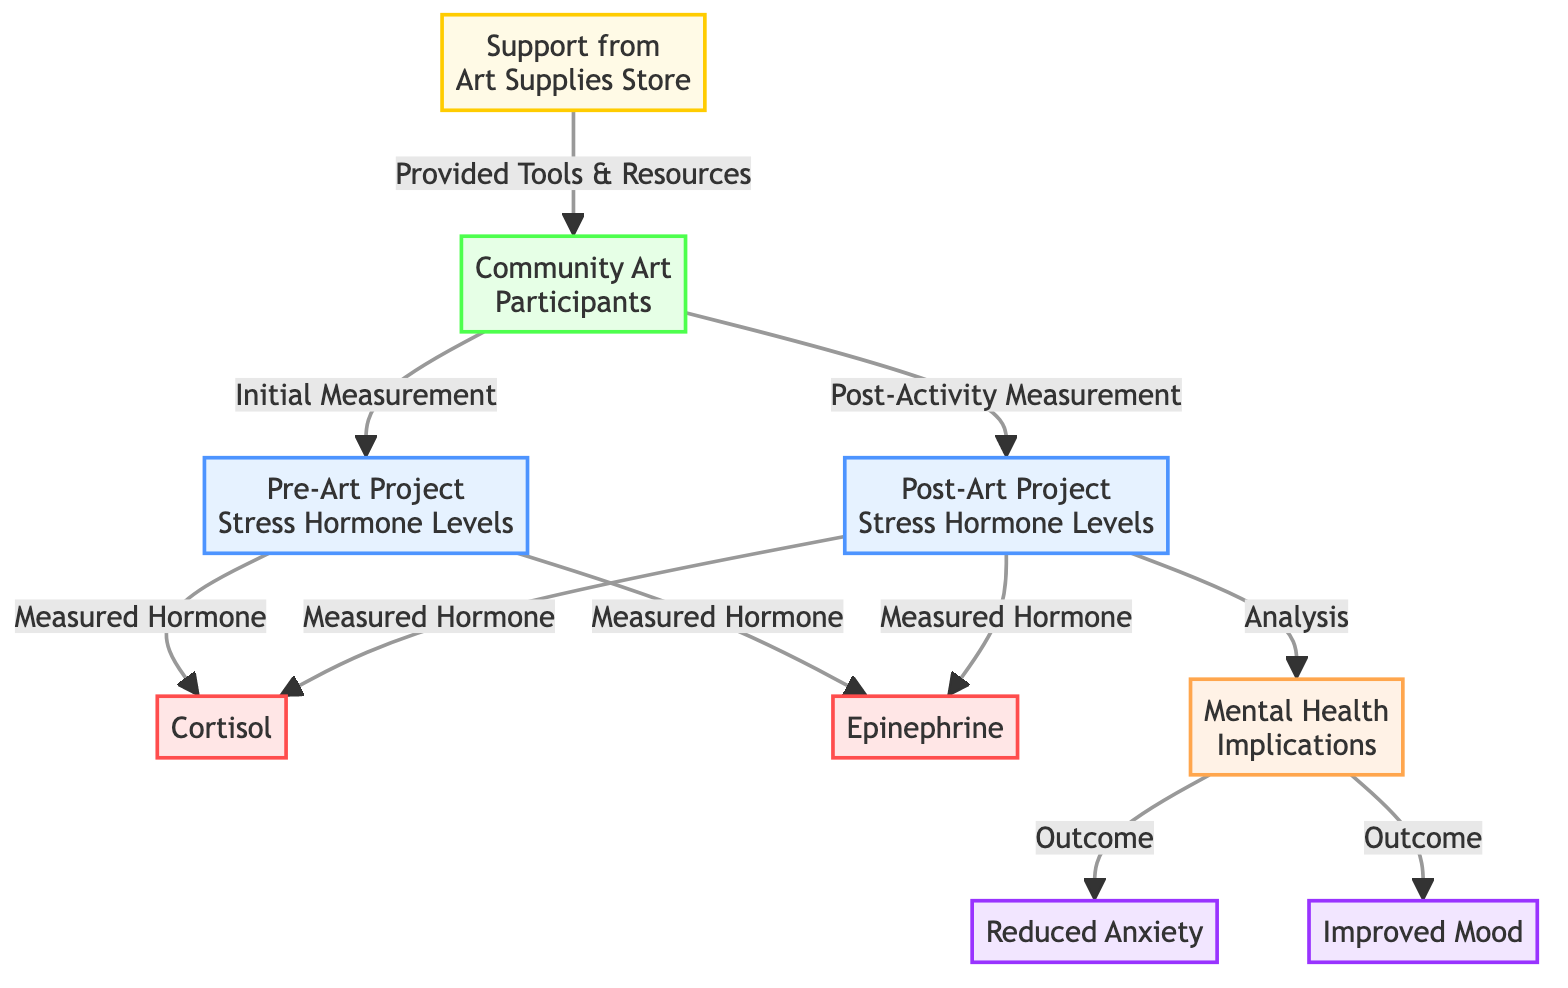What are the two types of stress hormones measured pre-Art Project? The diagram lists cortisol and epinephrine as the measured hormones before the art project, as indicated by the connections from the "Pre-Art Project Stress Hormone Levels" node.
Answer: Cortisol, Epinephrine How many groups are shown in the diagram? The diagram features one group labeled "Community Art Participants," which is the sole group represented in the relationships shown.
Answer: One What is the outcome of the post-activity hormonal analysis? The analysis of hormone levels after the activity leads to implications for mental health, demonstrated by the connection from the "Post-Art Project Stress Hormone Levels" node to the "Mental Health Implications" node.
Answer: Mental Health Implications What benefits are identified from engaging in community art projects? The diagram outlines two key benefits resulting from participation in community art projects: reduced anxiety and improved mood, both stemming from the "Mental Health Implications" node.
Answer: Reduced Anxiety, Improved Mood What provides support to the "Community Art Participants"? The diagram shows a connection from the "Support from Art Supplies Store," which indicates that art supplies and resources are provided to support the community participants in their projects.
Answer: Support from Art Supplies Store What hormone levels were measured after engaging in the art project? The diagram specifies that cortisol and epinephrine levels were again measured after the community art projects, noted through the connections from the "Post-Art Project Stress Hormone Levels" node.
Answer: Cortisol, Epinephrine What is the primary focus of the comparative analysis depicted in the diagram? The diagram illustrates a comparative analysis of stress hormone levels before and after engaging in community art projects, with emphasis on stress hormone levels and their relation to mental health outcomes.
Answer: Stress Hormone Levels Comparison What is the relationship between post-activity measurements and mental health? The diagram indicates that the post-activity measurements of stress hormones lead to an analysis that impacts mental health, connecting the analysis of hormone levels directly to the mental health outcomes.
Answer: Analysis impacts Mental Health 